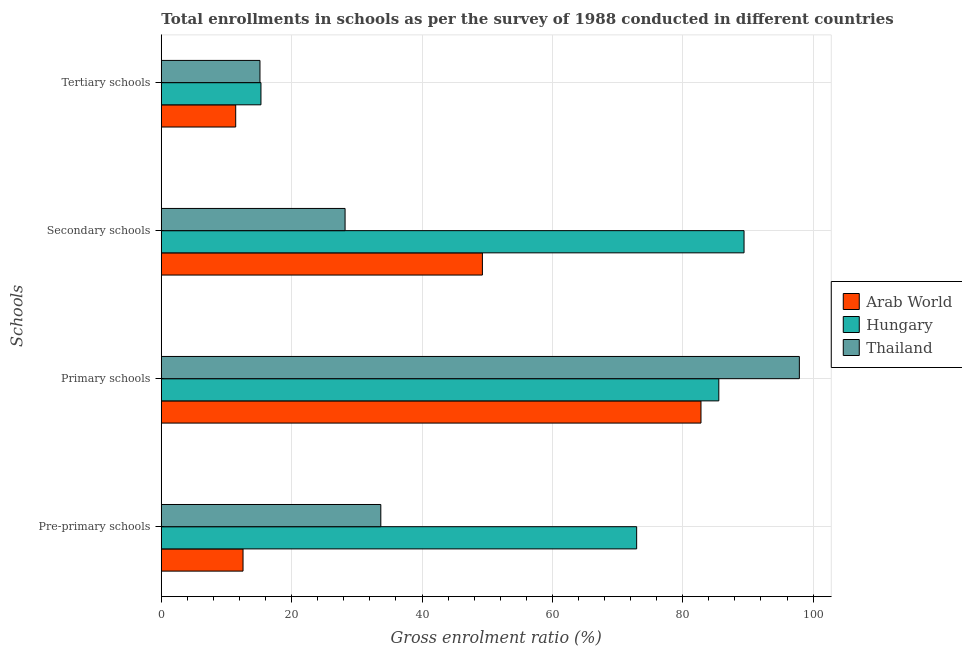How many different coloured bars are there?
Ensure brevity in your answer.  3. Are the number of bars on each tick of the Y-axis equal?
Your response must be concise. Yes. How many bars are there on the 4th tick from the bottom?
Ensure brevity in your answer.  3. What is the label of the 1st group of bars from the top?
Your answer should be very brief. Tertiary schools. What is the gross enrolment ratio in secondary schools in Thailand?
Provide a short and direct response. 28.2. Across all countries, what is the maximum gross enrolment ratio in primary schools?
Give a very brief answer. 97.9. Across all countries, what is the minimum gross enrolment ratio in secondary schools?
Offer a very short reply. 28.2. In which country was the gross enrolment ratio in primary schools maximum?
Ensure brevity in your answer.  Thailand. In which country was the gross enrolment ratio in tertiary schools minimum?
Ensure brevity in your answer.  Arab World. What is the total gross enrolment ratio in tertiary schools in the graph?
Make the answer very short. 41.84. What is the difference between the gross enrolment ratio in pre-primary schools in Thailand and that in Arab World?
Your answer should be very brief. 21.14. What is the difference between the gross enrolment ratio in primary schools in Arab World and the gross enrolment ratio in pre-primary schools in Thailand?
Your answer should be very brief. 49.13. What is the average gross enrolment ratio in pre-primary schools per country?
Your response must be concise. 39.72. What is the difference between the gross enrolment ratio in tertiary schools and gross enrolment ratio in primary schools in Hungary?
Offer a terse response. -70.25. What is the ratio of the gross enrolment ratio in pre-primary schools in Hungary to that in Arab World?
Your answer should be compact. 5.82. What is the difference between the highest and the second highest gross enrolment ratio in primary schools?
Give a very brief answer. 12.36. What is the difference between the highest and the lowest gross enrolment ratio in tertiary schools?
Keep it short and to the point. 3.87. In how many countries, is the gross enrolment ratio in pre-primary schools greater than the average gross enrolment ratio in pre-primary schools taken over all countries?
Your answer should be compact. 1. What does the 3rd bar from the top in Tertiary schools represents?
Make the answer very short. Arab World. What does the 1st bar from the bottom in Primary schools represents?
Your response must be concise. Arab World. How many countries are there in the graph?
Provide a short and direct response. 3. Are the values on the major ticks of X-axis written in scientific E-notation?
Your response must be concise. No. Does the graph contain grids?
Provide a short and direct response. Yes. How many legend labels are there?
Your answer should be compact. 3. What is the title of the graph?
Keep it short and to the point. Total enrollments in schools as per the survey of 1988 conducted in different countries. Does "Benin" appear as one of the legend labels in the graph?
Ensure brevity in your answer.  No. What is the label or title of the Y-axis?
Offer a terse response. Schools. What is the Gross enrolment ratio (%) in Arab World in Pre-primary schools?
Offer a very short reply. 12.54. What is the Gross enrolment ratio (%) of Hungary in Pre-primary schools?
Keep it short and to the point. 72.93. What is the Gross enrolment ratio (%) of Thailand in Pre-primary schools?
Your answer should be compact. 33.68. What is the Gross enrolment ratio (%) in Arab World in Primary schools?
Ensure brevity in your answer.  82.8. What is the Gross enrolment ratio (%) in Hungary in Primary schools?
Your response must be concise. 85.54. What is the Gross enrolment ratio (%) of Thailand in Primary schools?
Your answer should be compact. 97.9. What is the Gross enrolment ratio (%) of Arab World in Secondary schools?
Provide a succinct answer. 49.27. What is the Gross enrolment ratio (%) of Hungary in Secondary schools?
Keep it short and to the point. 89.41. What is the Gross enrolment ratio (%) of Thailand in Secondary schools?
Offer a very short reply. 28.2. What is the Gross enrolment ratio (%) in Arab World in Tertiary schools?
Keep it short and to the point. 11.41. What is the Gross enrolment ratio (%) in Hungary in Tertiary schools?
Give a very brief answer. 15.29. What is the Gross enrolment ratio (%) of Thailand in Tertiary schools?
Your answer should be very brief. 15.14. Across all Schools, what is the maximum Gross enrolment ratio (%) of Arab World?
Your answer should be compact. 82.8. Across all Schools, what is the maximum Gross enrolment ratio (%) in Hungary?
Keep it short and to the point. 89.41. Across all Schools, what is the maximum Gross enrolment ratio (%) of Thailand?
Ensure brevity in your answer.  97.9. Across all Schools, what is the minimum Gross enrolment ratio (%) in Arab World?
Ensure brevity in your answer.  11.41. Across all Schools, what is the minimum Gross enrolment ratio (%) of Hungary?
Provide a succinct answer. 15.29. Across all Schools, what is the minimum Gross enrolment ratio (%) in Thailand?
Provide a short and direct response. 15.14. What is the total Gross enrolment ratio (%) of Arab World in the graph?
Make the answer very short. 156.02. What is the total Gross enrolment ratio (%) in Hungary in the graph?
Ensure brevity in your answer.  263.17. What is the total Gross enrolment ratio (%) of Thailand in the graph?
Provide a succinct answer. 174.9. What is the difference between the Gross enrolment ratio (%) of Arab World in Pre-primary schools and that in Primary schools?
Ensure brevity in your answer.  -70.26. What is the difference between the Gross enrolment ratio (%) in Hungary in Pre-primary schools and that in Primary schools?
Your response must be concise. -12.6. What is the difference between the Gross enrolment ratio (%) of Thailand in Pre-primary schools and that in Primary schools?
Ensure brevity in your answer.  -64.22. What is the difference between the Gross enrolment ratio (%) of Arab World in Pre-primary schools and that in Secondary schools?
Make the answer very short. -36.73. What is the difference between the Gross enrolment ratio (%) in Hungary in Pre-primary schools and that in Secondary schools?
Offer a terse response. -16.48. What is the difference between the Gross enrolment ratio (%) in Thailand in Pre-primary schools and that in Secondary schools?
Give a very brief answer. 5.48. What is the difference between the Gross enrolment ratio (%) of Arab World in Pre-primary schools and that in Tertiary schools?
Ensure brevity in your answer.  1.12. What is the difference between the Gross enrolment ratio (%) of Hungary in Pre-primary schools and that in Tertiary schools?
Offer a very short reply. 57.65. What is the difference between the Gross enrolment ratio (%) in Thailand in Pre-primary schools and that in Tertiary schools?
Offer a terse response. 18.54. What is the difference between the Gross enrolment ratio (%) of Arab World in Primary schools and that in Secondary schools?
Ensure brevity in your answer.  33.54. What is the difference between the Gross enrolment ratio (%) in Hungary in Primary schools and that in Secondary schools?
Keep it short and to the point. -3.87. What is the difference between the Gross enrolment ratio (%) in Thailand in Primary schools and that in Secondary schools?
Your response must be concise. 69.7. What is the difference between the Gross enrolment ratio (%) of Arab World in Primary schools and that in Tertiary schools?
Your answer should be very brief. 71.39. What is the difference between the Gross enrolment ratio (%) in Hungary in Primary schools and that in Tertiary schools?
Ensure brevity in your answer.  70.25. What is the difference between the Gross enrolment ratio (%) of Thailand in Primary schools and that in Tertiary schools?
Your answer should be compact. 82.76. What is the difference between the Gross enrolment ratio (%) in Arab World in Secondary schools and that in Tertiary schools?
Ensure brevity in your answer.  37.85. What is the difference between the Gross enrolment ratio (%) in Hungary in Secondary schools and that in Tertiary schools?
Make the answer very short. 74.12. What is the difference between the Gross enrolment ratio (%) in Thailand in Secondary schools and that in Tertiary schools?
Your answer should be compact. 13.06. What is the difference between the Gross enrolment ratio (%) in Arab World in Pre-primary schools and the Gross enrolment ratio (%) in Hungary in Primary schools?
Keep it short and to the point. -73. What is the difference between the Gross enrolment ratio (%) in Arab World in Pre-primary schools and the Gross enrolment ratio (%) in Thailand in Primary schools?
Offer a terse response. -85.36. What is the difference between the Gross enrolment ratio (%) in Hungary in Pre-primary schools and the Gross enrolment ratio (%) in Thailand in Primary schools?
Give a very brief answer. -24.96. What is the difference between the Gross enrolment ratio (%) of Arab World in Pre-primary schools and the Gross enrolment ratio (%) of Hungary in Secondary schools?
Your answer should be compact. -76.87. What is the difference between the Gross enrolment ratio (%) in Arab World in Pre-primary schools and the Gross enrolment ratio (%) in Thailand in Secondary schools?
Ensure brevity in your answer.  -15.66. What is the difference between the Gross enrolment ratio (%) of Hungary in Pre-primary schools and the Gross enrolment ratio (%) of Thailand in Secondary schools?
Your response must be concise. 44.74. What is the difference between the Gross enrolment ratio (%) of Arab World in Pre-primary schools and the Gross enrolment ratio (%) of Hungary in Tertiary schools?
Offer a very short reply. -2.75. What is the difference between the Gross enrolment ratio (%) of Arab World in Pre-primary schools and the Gross enrolment ratio (%) of Thailand in Tertiary schools?
Your response must be concise. -2.6. What is the difference between the Gross enrolment ratio (%) in Hungary in Pre-primary schools and the Gross enrolment ratio (%) in Thailand in Tertiary schools?
Provide a succinct answer. 57.8. What is the difference between the Gross enrolment ratio (%) in Arab World in Primary schools and the Gross enrolment ratio (%) in Hungary in Secondary schools?
Provide a short and direct response. -6.61. What is the difference between the Gross enrolment ratio (%) in Arab World in Primary schools and the Gross enrolment ratio (%) in Thailand in Secondary schools?
Ensure brevity in your answer.  54.61. What is the difference between the Gross enrolment ratio (%) of Hungary in Primary schools and the Gross enrolment ratio (%) of Thailand in Secondary schools?
Your answer should be compact. 57.34. What is the difference between the Gross enrolment ratio (%) of Arab World in Primary schools and the Gross enrolment ratio (%) of Hungary in Tertiary schools?
Keep it short and to the point. 67.52. What is the difference between the Gross enrolment ratio (%) in Arab World in Primary schools and the Gross enrolment ratio (%) in Thailand in Tertiary schools?
Provide a succinct answer. 67.67. What is the difference between the Gross enrolment ratio (%) of Hungary in Primary schools and the Gross enrolment ratio (%) of Thailand in Tertiary schools?
Make the answer very short. 70.4. What is the difference between the Gross enrolment ratio (%) in Arab World in Secondary schools and the Gross enrolment ratio (%) in Hungary in Tertiary schools?
Keep it short and to the point. 33.98. What is the difference between the Gross enrolment ratio (%) in Arab World in Secondary schools and the Gross enrolment ratio (%) in Thailand in Tertiary schools?
Ensure brevity in your answer.  34.13. What is the difference between the Gross enrolment ratio (%) in Hungary in Secondary schools and the Gross enrolment ratio (%) in Thailand in Tertiary schools?
Ensure brevity in your answer.  74.27. What is the average Gross enrolment ratio (%) of Arab World per Schools?
Your response must be concise. 39.01. What is the average Gross enrolment ratio (%) in Hungary per Schools?
Your answer should be very brief. 65.79. What is the average Gross enrolment ratio (%) in Thailand per Schools?
Give a very brief answer. 43.73. What is the difference between the Gross enrolment ratio (%) in Arab World and Gross enrolment ratio (%) in Hungary in Pre-primary schools?
Provide a succinct answer. -60.39. What is the difference between the Gross enrolment ratio (%) of Arab World and Gross enrolment ratio (%) of Thailand in Pre-primary schools?
Offer a very short reply. -21.14. What is the difference between the Gross enrolment ratio (%) of Hungary and Gross enrolment ratio (%) of Thailand in Pre-primary schools?
Keep it short and to the point. 39.26. What is the difference between the Gross enrolment ratio (%) in Arab World and Gross enrolment ratio (%) in Hungary in Primary schools?
Your answer should be very brief. -2.73. What is the difference between the Gross enrolment ratio (%) in Arab World and Gross enrolment ratio (%) in Thailand in Primary schools?
Give a very brief answer. -15.09. What is the difference between the Gross enrolment ratio (%) of Hungary and Gross enrolment ratio (%) of Thailand in Primary schools?
Provide a succinct answer. -12.36. What is the difference between the Gross enrolment ratio (%) of Arab World and Gross enrolment ratio (%) of Hungary in Secondary schools?
Keep it short and to the point. -40.14. What is the difference between the Gross enrolment ratio (%) of Arab World and Gross enrolment ratio (%) of Thailand in Secondary schools?
Keep it short and to the point. 21.07. What is the difference between the Gross enrolment ratio (%) of Hungary and Gross enrolment ratio (%) of Thailand in Secondary schools?
Keep it short and to the point. 61.21. What is the difference between the Gross enrolment ratio (%) in Arab World and Gross enrolment ratio (%) in Hungary in Tertiary schools?
Ensure brevity in your answer.  -3.87. What is the difference between the Gross enrolment ratio (%) of Arab World and Gross enrolment ratio (%) of Thailand in Tertiary schools?
Offer a very short reply. -3.72. What is the difference between the Gross enrolment ratio (%) of Hungary and Gross enrolment ratio (%) of Thailand in Tertiary schools?
Offer a terse response. 0.15. What is the ratio of the Gross enrolment ratio (%) in Arab World in Pre-primary schools to that in Primary schools?
Make the answer very short. 0.15. What is the ratio of the Gross enrolment ratio (%) of Hungary in Pre-primary schools to that in Primary schools?
Your answer should be very brief. 0.85. What is the ratio of the Gross enrolment ratio (%) in Thailand in Pre-primary schools to that in Primary schools?
Offer a terse response. 0.34. What is the ratio of the Gross enrolment ratio (%) in Arab World in Pre-primary schools to that in Secondary schools?
Give a very brief answer. 0.25. What is the ratio of the Gross enrolment ratio (%) of Hungary in Pre-primary schools to that in Secondary schools?
Make the answer very short. 0.82. What is the ratio of the Gross enrolment ratio (%) in Thailand in Pre-primary schools to that in Secondary schools?
Keep it short and to the point. 1.19. What is the ratio of the Gross enrolment ratio (%) in Arab World in Pre-primary schools to that in Tertiary schools?
Your response must be concise. 1.1. What is the ratio of the Gross enrolment ratio (%) of Hungary in Pre-primary schools to that in Tertiary schools?
Your response must be concise. 4.77. What is the ratio of the Gross enrolment ratio (%) of Thailand in Pre-primary schools to that in Tertiary schools?
Your response must be concise. 2.23. What is the ratio of the Gross enrolment ratio (%) in Arab World in Primary schools to that in Secondary schools?
Keep it short and to the point. 1.68. What is the ratio of the Gross enrolment ratio (%) in Hungary in Primary schools to that in Secondary schools?
Give a very brief answer. 0.96. What is the ratio of the Gross enrolment ratio (%) in Thailand in Primary schools to that in Secondary schools?
Offer a terse response. 3.47. What is the ratio of the Gross enrolment ratio (%) in Arab World in Primary schools to that in Tertiary schools?
Offer a terse response. 7.25. What is the ratio of the Gross enrolment ratio (%) of Hungary in Primary schools to that in Tertiary schools?
Make the answer very short. 5.6. What is the ratio of the Gross enrolment ratio (%) of Thailand in Primary schools to that in Tertiary schools?
Keep it short and to the point. 6.47. What is the ratio of the Gross enrolment ratio (%) of Arab World in Secondary schools to that in Tertiary schools?
Offer a very short reply. 4.32. What is the ratio of the Gross enrolment ratio (%) of Hungary in Secondary schools to that in Tertiary schools?
Your response must be concise. 5.85. What is the ratio of the Gross enrolment ratio (%) of Thailand in Secondary schools to that in Tertiary schools?
Offer a very short reply. 1.86. What is the difference between the highest and the second highest Gross enrolment ratio (%) of Arab World?
Keep it short and to the point. 33.54. What is the difference between the highest and the second highest Gross enrolment ratio (%) in Hungary?
Offer a very short reply. 3.87. What is the difference between the highest and the second highest Gross enrolment ratio (%) in Thailand?
Ensure brevity in your answer.  64.22. What is the difference between the highest and the lowest Gross enrolment ratio (%) in Arab World?
Your response must be concise. 71.39. What is the difference between the highest and the lowest Gross enrolment ratio (%) of Hungary?
Offer a terse response. 74.12. What is the difference between the highest and the lowest Gross enrolment ratio (%) of Thailand?
Ensure brevity in your answer.  82.76. 